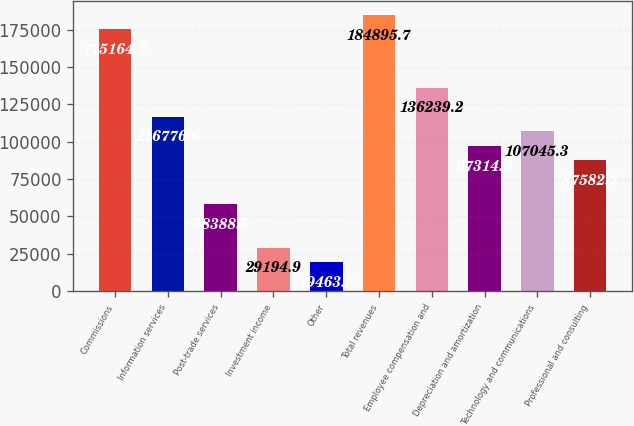Convert chart. <chart><loc_0><loc_0><loc_500><loc_500><bar_chart><fcel>Commissions<fcel>Information services<fcel>Post-trade services<fcel>Investment income<fcel>Other<fcel>Total revenues<fcel>Employee compensation and<fcel>Depreciation and amortization<fcel>Technology and communications<fcel>Professional and consulting<nl><fcel>175164<fcel>116777<fcel>58388.8<fcel>29194.9<fcel>19463.6<fcel>184896<fcel>136239<fcel>97314<fcel>107045<fcel>87582.7<nl></chart> 